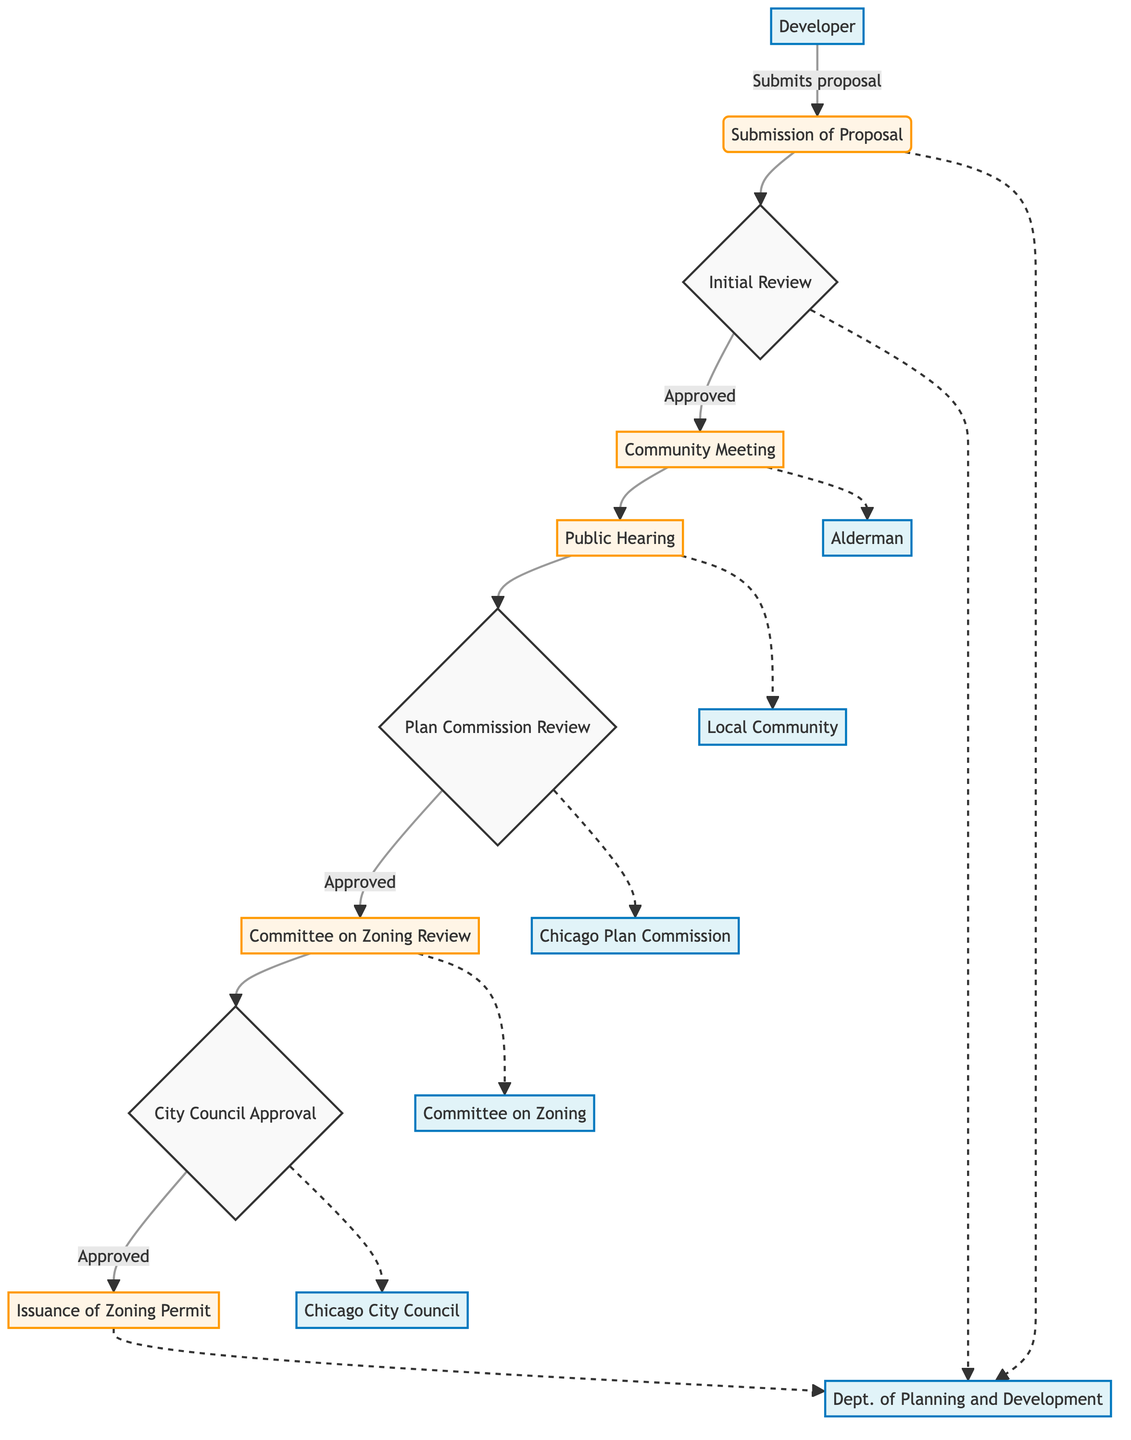What is the first step in the zoning approval process? The first step in the process, as depicted in the diagram, is "Submission of Proposal," where the developer submits a detailed proposal to the Department of Planning and Development.
Answer: Submission of Proposal How many key entities are involved in the process? The diagram lists seven key entities, which are Developer, Department of Planning and Development, Alderman, Local Community, Chicago Plan Commission, Chicago City Council, and Committee on Zoning, Landmarks and Building Standards.
Answer: Seven What happens after the Initial Review if approved? After the "Initial Review," if it is approved, the next step is the "Community Meeting," where developers present their proposed development at a local community meeting organized by the alderman.
Answer: Community Meeting What is the relationship between Public Hearing and Plan Commission Review? The "Public Hearing" precedes the "Plan Commission Review." After the public hearing, the Chicago Plan Commission conducts a review of the proposal for adherence to city planning and zoning ordinances.
Answer: Precedes If the Proposal is not approved in the Plan Commission Review, what happens? If the proposal is not approved during the "Plan Commission Review," it will not proceed to the "Committee on Zoning Review" and ultimately will not reach "City Council Approval." The specific path is not shown in the diagram, but logically, further steps will cease without approval.
Answer: Stops Which key entity issues the zoning permit? The zoning permit is issued by the "Department of Planning and Development" upon approval by the City Council. This is explicitly indicated at the end of the process in the diagram.
Answer: Department of Planning and Development What step follows City Council Approval? Following the "City Council Approval," the next step is the "Issuance of Zoning Permit," which confirms that the process concludes with the official issuance of permits allowing the development to proceed.
Answer: Issuance of Zoning Permit What type of input is considered during the Public Hearing? The "Public Hearing" is conducted for "community input," indicating that feedback from local residents and other stakeholders is gathered to be considered in the review process.
Answer: Community input How do the Developer and Alderman interact in the process? The Developer presents the proposal during the "Community Meeting," which is organized by the Alderman. This shows that the Alderman plays a role in facilitating communication between the Developer and the local community.
Answer: Community Meeting 